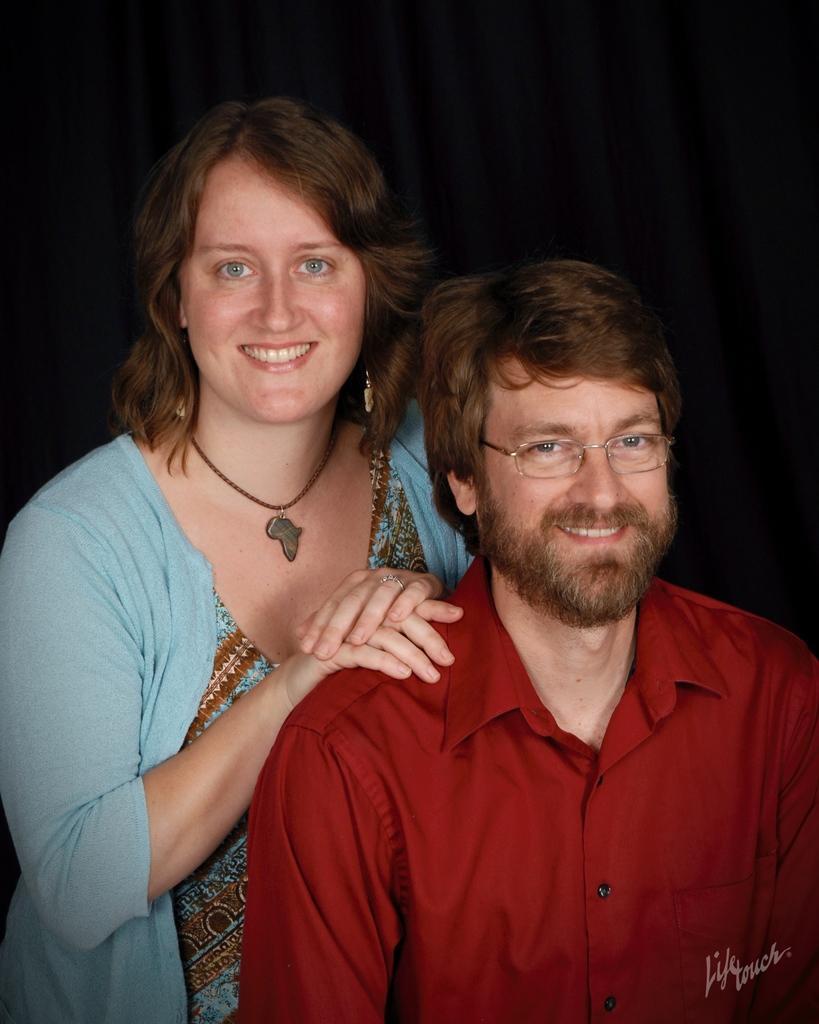How would you summarize this image in a sentence or two? In the image we can see there are man and woman in the picture and they are smiling. Behind there is a black curtain and woman is wearing a necklace around her neck. 